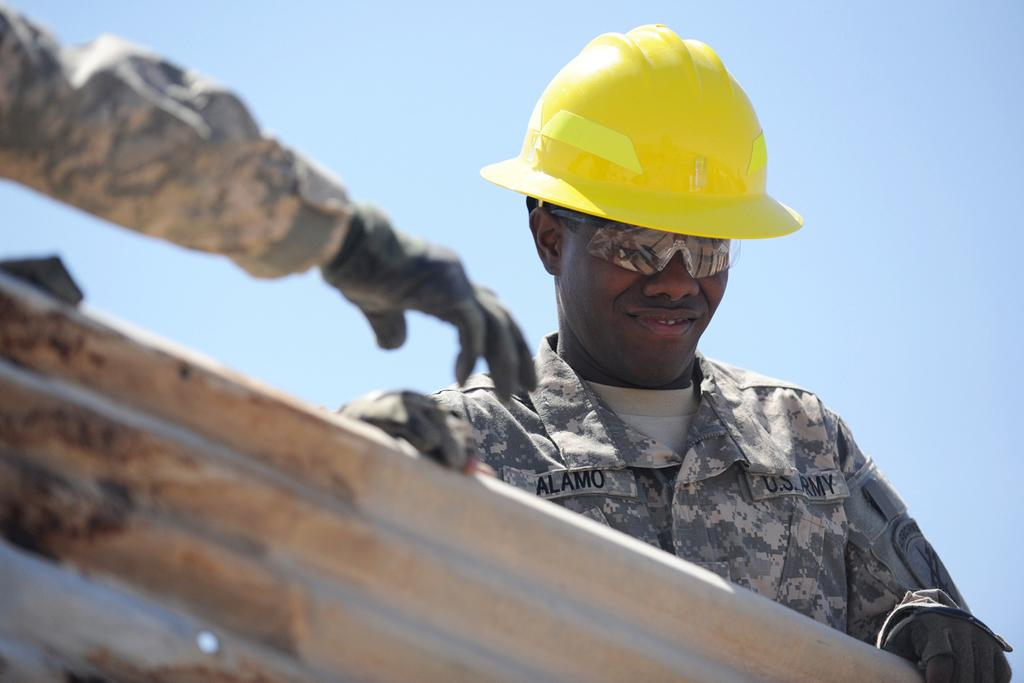Who is present in the image? There is a man in the image. What is the man wearing on his face? The man is wearing spectacles. What is the man wearing on his head? The man is wearing a yellow color helmet on his head. What can be seen on the left side of the image? There is a human hand on the left side of the image. What is visible in the background of the image? The sky is visible in the background of the image. What time of day is it in the image, based on the hour hand of the clock? There is no clock or hour hand present in the image, so it is not possible to determine the time of day. 